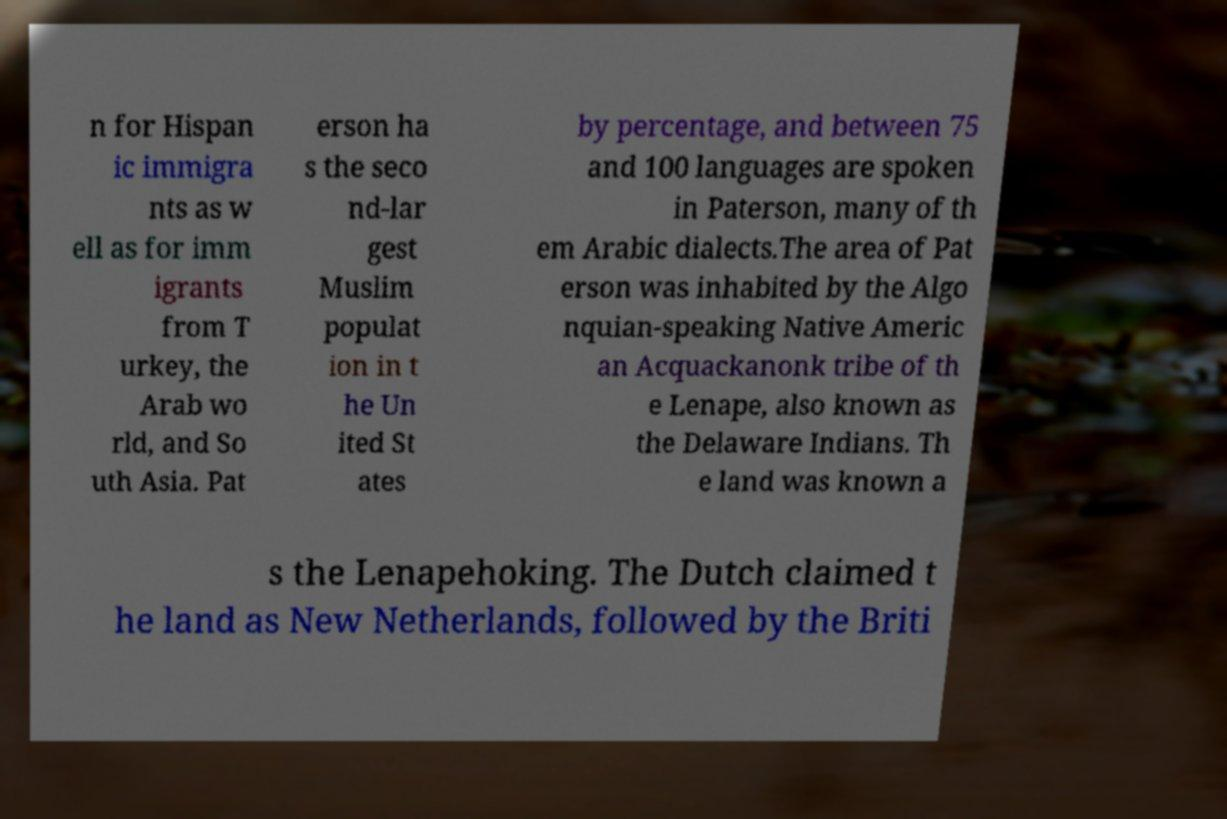Could you assist in decoding the text presented in this image and type it out clearly? n for Hispan ic immigra nts as w ell as for imm igrants from T urkey, the Arab wo rld, and So uth Asia. Pat erson ha s the seco nd-lar gest Muslim populat ion in t he Un ited St ates by percentage, and between 75 and 100 languages are spoken in Paterson, many of th em Arabic dialects.The area of Pat erson was inhabited by the Algo nquian-speaking Native Americ an Acquackanonk tribe of th e Lenape, also known as the Delaware Indians. Th e land was known a s the Lenapehoking. The Dutch claimed t he land as New Netherlands, followed by the Briti 